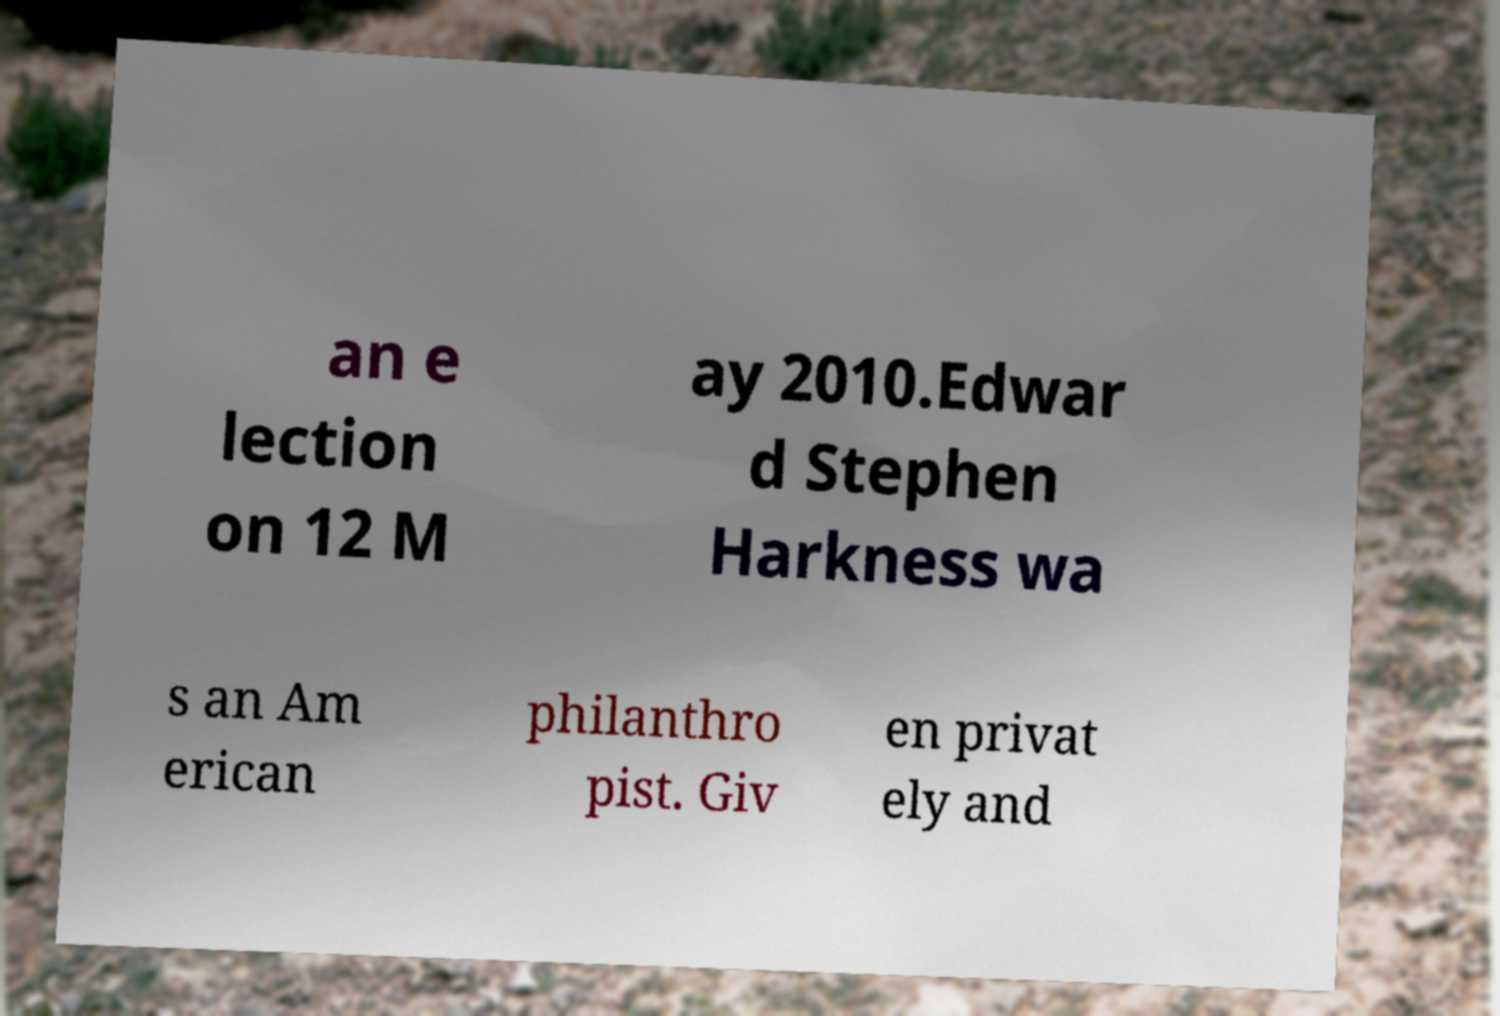What messages or text are displayed in this image? I need them in a readable, typed format. an e lection on 12 M ay 2010.Edwar d Stephen Harkness wa s an Am erican philanthro pist. Giv en privat ely and 